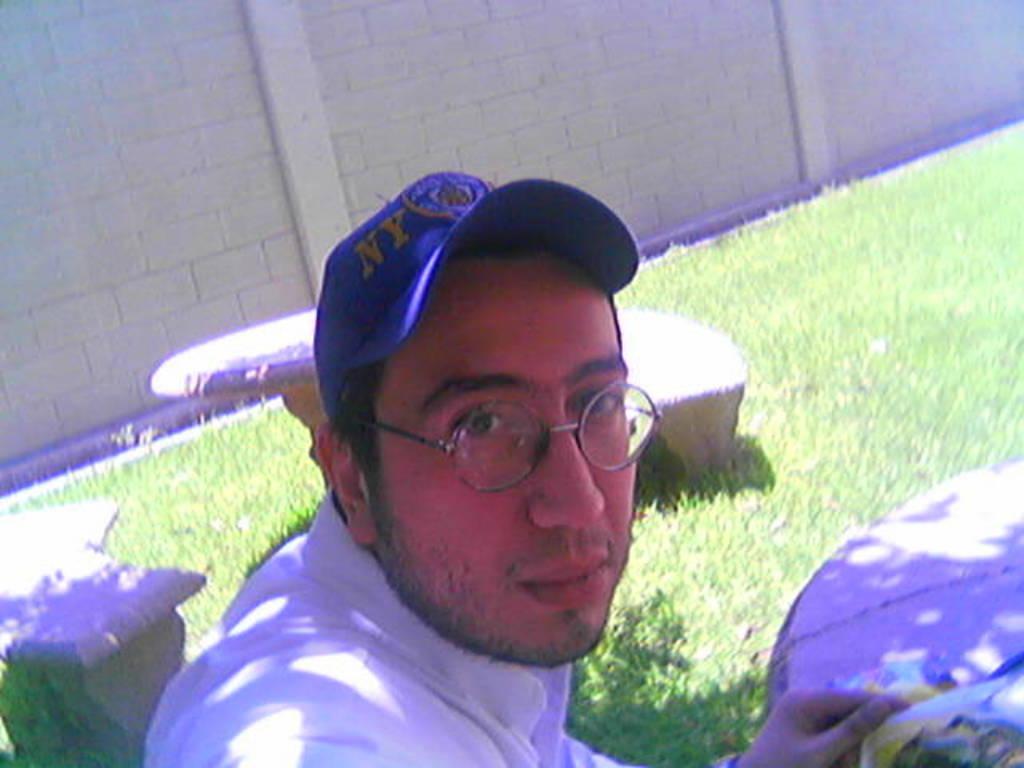Please provide a concise description of this image. In this image we can see a man wearing the glasses and also the cap. We can also see two benches and two tables. In the background, we can see the wall and also the grass. 